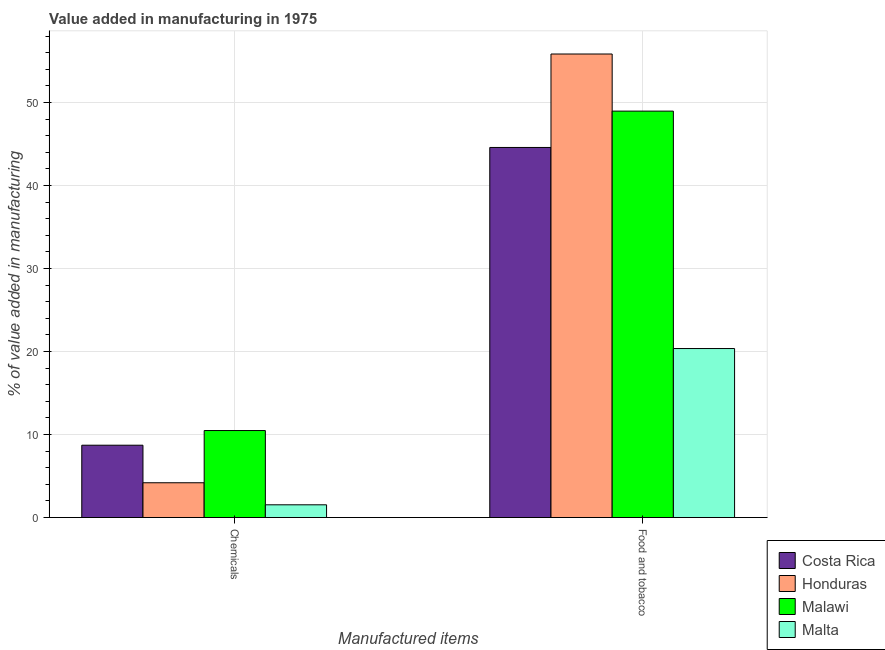How many different coloured bars are there?
Provide a succinct answer. 4. How many groups of bars are there?
Keep it short and to the point. 2. Are the number of bars per tick equal to the number of legend labels?
Your answer should be compact. Yes. How many bars are there on the 1st tick from the left?
Make the answer very short. 4. What is the label of the 1st group of bars from the left?
Keep it short and to the point. Chemicals. What is the value added by manufacturing food and tobacco in Honduras?
Offer a very short reply. 55.85. Across all countries, what is the maximum value added by manufacturing food and tobacco?
Provide a short and direct response. 55.85. Across all countries, what is the minimum value added by  manufacturing chemicals?
Ensure brevity in your answer.  1.54. In which country was the value added by manufacturing food and tobacco maximum?
Ensure brevity in your answer.  Honduras. In which country was the value added by manufacturing food and tobacco minimum?
Your response must be concise. Malta. What is the total value added by  manufacturing chemicals in the graph?
Keep it short and to the point. 24.93. What is the difference between the value added by manufacturing food and tobacco in Honduras and that in Costa Rica?
Your answer should be very brief. 11.26. What is the difference between the value added by manufacturing food and tobacco in Honduras and the value added by  manufacturing chemicals in Malawi?
Your response must be concise. 45.37. What is the average value added by manufacturing food and tobacco per country?
Make the answer very short. 42.44. What is the difference between the value added by manufacturing food and tobacco and value added by  manufacturing chemicals in Costa Rica?
Provide a short and direct response. 35.87. What is the ratio of the value added by manufacturing food and tobacco in Malawi to that in Costa Rica?
Ensure brevity in your answer.  1.1. Is the value added by manufacturing food and tobacco in Malawi less than that in Honduras?
Make the answer very short. Yes. In how many countries, is the value added by  manufacturing chemicals greater than the average value added by  manufacturing chemicals taken over all countries?
Provide a short and direct response. 2. What does the 4th bar from the left in Food and tobacco represents?
Your response must be concise. Malta. What does the 3rd bar from the right in Chemicals represents?
Provide a short and direct response. Honduras. How many bars are there?
Offer a terse response. 8. What is the difference between two consecutive major ticks on the Y-axis?
Provide a succinct answer. 10. Are the values on the major ticks of Y-axis written in scientific E-notation?
Keep it short and to the point. No. Does the graph contain grids?
Provide a short and direct response. Yes. Where does the legend appear in the graph?
Offer a terse response. Bottom right. How many legend labels are there?
Your answer should be very brief. 4. What is the title of the graph?
Make the answer very short. Value added in manufacturing in 1975. Does "Hungary" appear as one of the legend labels in the graph?
Give a very brief answer. No. What is the label or title of the X-axis?
Offer a terse response. Manufactured items. What is the label or title of the Y-axis?
Provide a short and direct response. % of value added in manufacturing. What is the % of value added in manufacturing in Costa Rica in Chemicals?
Give a very brief answer. 8.72. What is the % of value added in manufacturing in Honduras in Chemicals?
Offer a terse response. 4.19. What is the % of value added in manufacturing of Malawi in Chemicals?
Offer a very short reply. 10.49. What is the % of value added in manufacturing of Malta in Chemicals?
Ensure brevity in your answer.  1.54. What is the % of value added in manufacturing in Costa Rica in Food and tobacco?
Give a very brief answer. 44.59. What is the % of value added in manufacturing of Honduras in Food and tobacco?
Keep it short and to the point. 55.85. What is the % of value added in manufacturing of Malawi in Food and tobacco?
Make the answer very short. 48.97. What is the % of value added in manufacturing of Malta in Food and tobacco?
Provide a short and direct response. 20.36. Across all Manufactured items, what is the maximum % of value added in manufacturing of Costa Rica?
Your answer should be compact. 44.59. Across all Manufactured items, what is the maximum % of value added in manufacturing of Honduras?
Your answer should be compact. 55.85. Across all Manufactured items, what is the maximum % of value added in manufacturing in Malawi?
Offer a very short reply. 48.97. Across all Manufactured items, what is the maximum % of value added in manufacturing of Malta?
Keep it short and to the point. 20.36. Across all Manufactured items, what is the minimum % of value added in manufacturing of Costa Rica?
Your response must be concise. 8.72. Across all Manufactured items, what is the minimum % of value added in manufacturing in Honduras?
Your answer should be very brief. 4.19. Across all Manufactured items, what is the minimum % of value added in manufacturing in Malawi?
Your response must be concise. 10.49. Across all Manufactured items, what is the minimum % of value added in manufacturing of Malta?
Provide a succinct answer. 1.54. What is the total % of value added in manufacturing of Costa Rica in the graph?
Your response must be concise. 53.31. What is the total % of value added in manufacturing of Honduras in the graph?
Keep it short and to the point. 60.05. What is the total % of value added in manufacturing in Malawi in the graph?
Your answer should be compact. 59.46. What is the total % of value added in manufacturing of Malta in the graph?
Ensure brevity in your answer.  21.9. What is the difference between the % of value added in manufacturing of Costa Rica in Chemicals and that in Food and tobacco?
Give a very brief answer. -35.87. What is the difference between the % of value added in manufacturing of Honduras in Chemicals and that in Food and tobacco?
Your answer should be very brief. -51.66. What is the difference between the % of value added in manufacturing in Malawi in Chemicals and that in Food and tobacco?
Provide a succinct answer. -38.49. What is the difference between the % of value added in manufacturing of Malta in Chemicals and that in Food and tobacco?
Give a very brief answer. -18.83. What is the difference between the % of value added in manufacturing of Costa Rica in Chemicals and the % of value added in manufacturing of Honduras in Food and tobacco?
Offer a terse response. -47.14. What is the difference between the % of value added in manufacturing in Costa Rica in Chemicals and the % of value added in manufacturing in Malawi in Food and tobacco?
Offer a very short reply. -40.25. What is the difference between the % of value added in manufacturing in Costa Rica in Chemicals and the % of value added in manufacturing in Malta in Food and tobacco?
Offer a terse response. -11.65. What is the difference between the % of value added in manufacturing of Honduras in Chemicals and the % of value added in manufacturing of Malawi in Food and tobacco?
Offer a very short reply. -44.78. What is the difference between the % of value added in manufacturing in Honduras in Chemicals and the % of value added in manufacturing in Malta in Food and tobacco?
Offer a very short reply. -16.17. What is the difference between the % of value added in manufacturing in Malawi in Chemicals and the % of value added in manufacturing in Malta in Food and tobacco?
Make the answer very short. -9.88. What is the average % of value added in manufacturing in Costa Rica per Manufactured items?
Give a very brief answer. 26.65. What is the average % of value added in manufacturing in Honduras per Manufactured items?
Offer a very short reply. 30.02. What is the average % of value added in manufacturing of Malawi per Manufactured items?
Provide a succinct answer. 29.73. What is the average % of value added in manufacturing in Malta per Manufactured items?
Your answer should be compact. 10.95. What is the difference between the % of value added in manufacturing of Costa Rica and % of value added in manufacturing of Honduras in Chemicals?
Your response must be concise. 4.52. What is the difference between the % of value added in manufacturing of Costa Rica and % of value added in manufacturing of Malawi in Chemicals?
Your answer should be very brief. -1.77. What is the difference between the % of value added in manufacturing in Costa Rica and % of value added in manufacturing in Malta in Chemicals?
Offer a terse response. 7.18. What is the difference between the % of value added in manufacturing of Honduras and % of value added in manufacturing of Malawi in Chemicals?
Make the answer very short. -6.29. What is the difference between the % of value added in manufacturing in Honduras and % of value added in manufacturing in Malta in Chemicals?
Give a very brief answer. 2.66. What is the difference between the % of value added in manufacturing in Malawi and % of value added in manufacturing in Malta in Chemicals?
Offer a very short reply. 8.95. What is the difference between the % of value added in manufacturing in Costa Rica and % of value added in manufacturing in Honduras in Food and tobacco?
Offer a terse response. -11.26. What is the difference between the % of value added in manufacturing in Costa Rica and % of value added in manufacturing in Malawi in Food and tobacco?
Your answer should be very brief. -4.38. What is the difference between the % of value added in manufacturing in Costa Rica and % of value added in manufacturing in Malta in Food and tobacco?
Ensure brevity in your answer.  24.23. What is the difference between the % of value added in manufacturing in Honduras and % of value added in manufacturing in Malawi in Food and tobacco?
Keep it short and to the point. 6.88. What is the difference between the % of value added in manufacturing in Honduras and % of value added in manufacturing in Malta in Food and tobacco?
Offer a terse response. 35.49. What is the difference between the % of value added in manufacturing in Malawi and % of value added in manufacturing in Malta in Food and tobacco?
Your response must be concise. 28.61. What is the ratio of the % of value added in manufacturing of Costa Rica in Chemicals to that in Food and tobacco?
Ensure brevity in your answer.  0.2. What is the ratio of the % of value added in manufacturing of Honduras in Chemicals to that in Food and tobacco?
Make the answer very short. 0.08. What is the ratio of the % of value added in manufacturing in Malawi in Chemicals to that in Food and tobacco?
Give a very brief answer. 0.21. What is the ratio of the % of value added in manufacturing in Malta in Chemicals to that in Food and tobacco?
Make the answer very short. 0.08. What is the difference between the highest and the second highest % of value added in manufacturing in Costa Rica?
Ensure brevity in your answer.  35.87. What is the difference between the highest and the second highest % of value added in manufacturing of Honduras?
Offer a terse response. 51.66. What is the difference between the highest and the second highest % of value added in manufacturing in Malawi?
Provide a short and direct response. 38.49. What is the difference between the highest and the second highest % of value added in manufacturing of Malta?
Your answer should be compact. 18.83. What is the difference between the highest and the lowest % of value added in manufacturing in Costa Rica?
Offer a very short reply. 35.87. What is the difference between the highest and the lowest % of value added in manufacturing in Honduras?
Your answer should be compact. 51.66. What is the difference between the highest and the lowest % of value added in manufacturing of Malawi?
Give a very brief answer. 38.49. What is the difference between the highest and the lowest % of value added in manufacturing in Malta?
Ensure brevity in your answer.  18.83. 